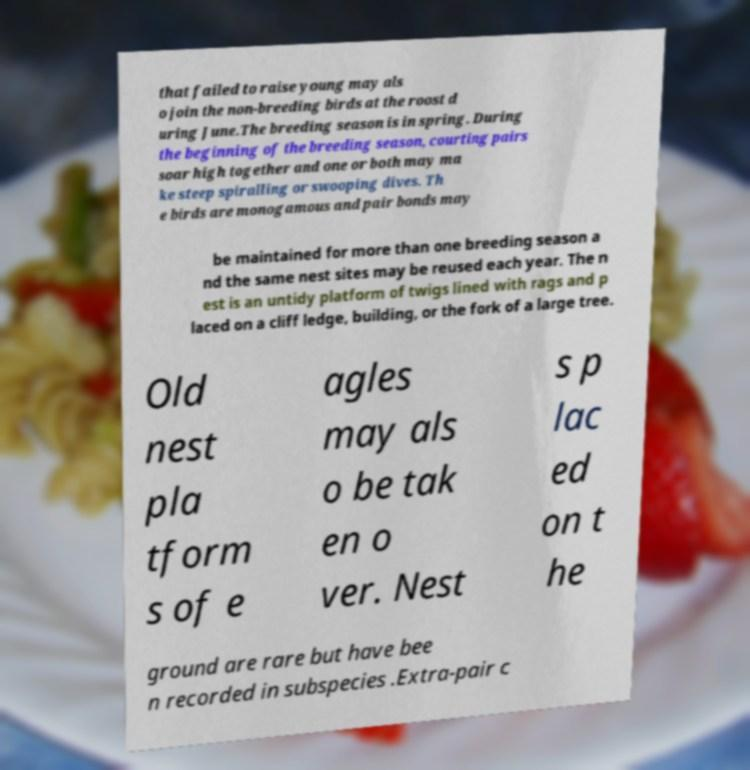Could you extract and type out the text from this image? that failed to raise young may als o join the non-breeding birds at the roost d uring June.The breeding season is in spring. During the beginning of the breeding season, courting pairs soar high together and one or both may ma ke steep spiralling or swooping dives. Th e birds are monogamous and pair bonds may be maintained for more than one breeding season a nd the same nest sites may be reused each year. The n est is an untidy platform of twigs lined with rags and p laced on a cliff ledge, building, or the fork of a large tree. Old nest pla tform s of e agles may als o be tak en o ver. Nest s p lac ed on t he ground are rare but have bee n recorded in subspecies .Extra-pair c 